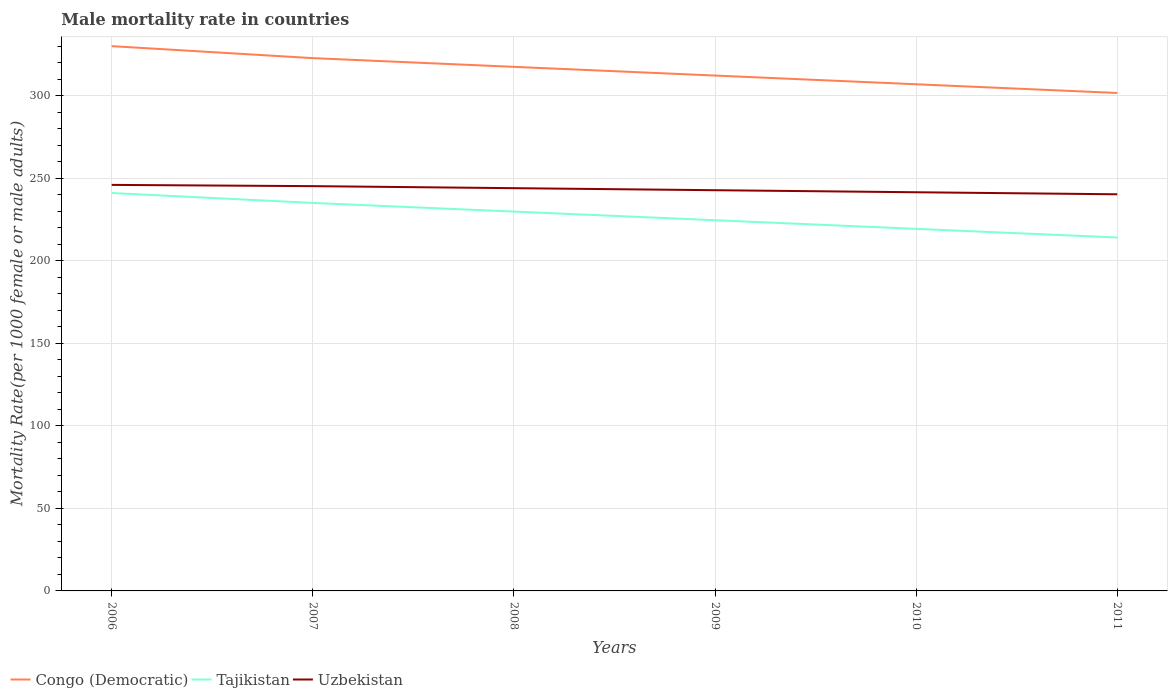Is the number of lines equal to the number of legend labels?
Provide a short and direct response. Yes. Across all years, what is the maximum male mortality rate in Uzbekistan?
Give a very brief answer. 240.42. What is the total male mortality rate in Uzbekistan in the graph?
Offer a terse response. 5.69. What is the difference between the highest and the second highest male mortality rate in Congo (Democratic)?
Keep it short and to the point. 28.38. Is the male mortality rate in Congo (Democratic) strictly greater than the male mortality rate in Uzbekistan over the years?
Ensure brevity in your answer.  No. How many lines are there?
Provide a short and direct response. 3. Does the graph contain any zero values?
Make the answer very short. No. Does the graph contain grids?
Offer a terse response. Yes. How many legend labels are there?
Provide a short and direct response. 3. What is the title of the graph?
Your answer should be very brief. Male mortality rate in countries. What is the label or title of the Y-axis?
Offer a terse response. Mortality Rate(per 1000 female or male adults). What is the Mortality Rate(per 1000 female or male adults) in Congo (Democratic) in 2006?
Provide a succinct answer. 330.21. What is the Mortality Rate(per 1000 female or male adults) of Tajikistan in 2006?
Keep it short and to the point. 241.19. What is the Mortality Rate(per 1000 female or male adults) in Uzbekistan in 2006?
Provide a succinct answer. 246.11. What is the Mortality Rate(per 1000 female or male adults) in Congo (Democratic) in 2007?
Your response must be concise. 322.95. What is the Mortality Rate(per 1000 female or male adults) of Tajikistan in 2007?
Give a very brief answer. 235.18. What is the Mortality Rate(per 1000 female or male adults) in Uzbekistan in 2007?
Offer a terse response. 245.36. What is the Mortality Rate(per 1000 female or male adults) of Congo (Democratic) in 2008?
Offer a terse response. 317.67. What is the Mortality Rate(per 1000 female or male adults) in Tajikistan in 2008?
Offer a terse response. 229.94. What is the Mortality Rate(per 1000 female or male adults) in Uzbekistan in 2008?
Your answer should be compact. 244.12. What is the Mortality Rate(per 1000 female or male adults) of Congo (Democratic) in 2009?
Offer a very short reply. 312.39. What is the Mortality Rate(per 1000 female or male adults) in Tajikistan in 2009?
Your answer should be compact. 224.7. What is the Mortality Rate(per 1000 female or male adults) of Uzbekistan in 2009?
Provide a succinct answer. 242.89. What is the Mortality Rate(per 1000 female or male adults) of Congo (Democratic) in 2010?
Provide a short and direct response. 307.11. What is the Mortality Rate(per 1000 female or male adults) of Tajikistan in 2010?
Offer a terse response. 219.47. What is the Mortality Rate(per 1000 female or male adults) in Uzbekistan in 2010?
Offer a very short reply. 241.65. What is the Mortality Rate(per 1000 female or male adults) of Congo (Democratic) in 2011?
Give a very brief answer. 301.83. What is the Mortality Rate(per 1000 female or male adults) in Tajikistan in 2011?
Your answer should be very brief. 214.23. What is the Mortality Rate(per 1000 female or male adults) of Uzbekistan in 2011?
Ensure brevity in your answer.  240.42. Across all years, what is the maximum Mortality Rate(per 1000 female or male adults) in Congo (Democratic)?
Ensure brevity in your answer.  330.21. Across all years, what is the maximum Mortality Rate(per 1000 female or male adults) of Tajikistan?
Ensure brevity in your answer.  241.19. Across all years, what is the maximum Mortality Rate(per 1000 female or male adults) in Uzbekistan?
Make the answer very short. 246.11. Across all years, what is the minimum Mortality Rate(per 1000 female or male adults) of Congo (Democratic)?
Make the answer very short. 301.83. Across all years, what is the minimum Mortality Rate(per 1000 female or male adults) of Tajikistan?
Keep it short and to the point. 214.23. Across all years, what is the minimum Mortality Rate(per 1000 female or male adults) of Uzbekistan?
Give a very brief answer. 240.42. What is the total Mortality Rate(per 1000 female or male adults) in Congo (Democratic) in the graph?
Provide a short and direct response. 1892.17. What is the total Mortality Rate(per 1000 female or male adults) in Tajikistan in the graph?
Provide a succinct answer. 1364.7. What is the total Mortality Rate(per 1000 female or male adults) in Uzbekistan in the graph?
Your answer should be very brief. 1460.56. What is the difference between the Mortality Rate(per 1000 female or male adults) in Congo (Democratic) in 2006 and that in 2007?
Give a very brief answer. 7.26. What is the difference between the Mortality Rate(per 1000 female or male adults) in Tajikistan in 2006 and that in 2007?
Provide a short and direct response. 6.01. What is the difference between the Mortality Rate(per 1000 female or male adults) of Uzbekistan in 2006 and that in 2007?
Provide a short and direct response. 0.75. What is the difference between the Mortality Rate(per 1000 female or male adults) in Congo (Democratic) in 2006 and that in 2008?
Your answer should be very brief. 12.54. What is the difference between the Mortality Rate(per 1000 female or male adults) in Tajikistan in 2006 and that in 2008?
Give a very brief answer. 11.25. What is the difference between the Mortality Rate(per 1000 female or male adults) of Uzbekistan in 2006 and that in 2008?
Give a very brief answer. 1.99. What is the difference between the Mortality Rate(per 1000 female or male adults) in Congo (Democratic) in 2006 and that in 2009?
Give a very brief answer. 17.82. What is the difference between the Mortality Rate(per 1000 female or male adults) in Tajikistan in 2006 and that in 2009?
Provide a succinct answer. 16.48. What is the difference between the Mortality Rate(per 1000 female or male adults) of Uzbekistan in 2006 and that in 2009?
Your response must be concise. 3.22. What is the difference between the Mortality Rate(per 1000 female or male adults) of Congo (Democratic) in 2006 and that in 2010?
Your answer should be very brief. 23.1. What is the difference between the Mortality Rate(per 1000 female or male adults) in Tajikistan in 2006 and that in 2010?
Keep it short and to the point. 21.72. What is the difference between the Mortality Rate(per 1000 female or male adults) of Uzbekistan in 2006 and that in 2010?
Your answer should be compact. 4.46. What is the difference between the Mortality Rate(per 1000 female or male adults) in Congo (Democratic) in 2006 and that in 2011?
Offer a terse response. 28.38. What is the difference between the Mortality Rate(per 1000 female or male adults) of Tajikistan in 2006 and that in 2011?
Your answer should be compact. 26.96. What is the difference between the Mortality Rate(per 1000 female or male adults) in Uzbekistan in 2006 and that in 2011?
Your answer should be compact. 5.69. What is the difference between the Mortality Rate(per 1000 female or male adults) in Congo (Democratic) in 2007 and that in 2008?
Offer a terse response. 5.28. What is the difference between the Mortality Rate(per 1000 female or male adults) in Tajikistan in 2007 and that in 2008?
Your answer should be compact. 5.24. What is the difference between the Mortality Rate(per 1000 female or male adults) in Uzbekistan in 2007 and that in 2008?
Keep it short and to the point. 1.24. What is the difference between the Mortality Rate(per 1000 female or male adults) of Congo (Democratic) in 2007 and that in 2009?
Ensure brevity in your answer.  10.56. What is the difference between the Mortality Rate(per 1000 female or male adults) of Tajikistan in 2007 and that in 2009?
Provide a succinct answer. 10.48. What is the difference between the Mortality Rate(per 1000 female or male adults) in Uzbekistan in 2007 and that in 2009?
Give a very brief answer. 2.47. What is the difference between the Mortality Rate(per 1000 female or male adults) in Congo (Democratic) in 2007 and that in 2010?
Make the answer very short. 15.84. What is the difference between the Mortality Rate(per 1000 female or male adults) of Tajikistan in 2007 and that in 2010?
Offer a terse response. 15.71. What is the difference between the Mortality Rate(per 1000 female or male adults) of Uzbekistan in 2007 and that in 2010?
Provide a succinct answer. 3.71. What is the difference between the Mortality Rate(per 1000 female or male adults) of Congo (Democratic) in 2007 and that in 2011?
Provide a short and direct response. 21.12. What is the difference between the Mortality Rate(per 1000 female or male adults) in Tajikistan in 2007 and that in 2011?
Keep it short and to the point. 20.95. What is the difference between the Mortality Rate(per 1000 female or male adults) in Uzbekistan in 2007 and that in 2011?
Give a very brief answer. 4.94. What is the difference between the Mortality Rate(per 1000 female or male adults) in Congo (Democratic) in 2008 and that in 2009?
Keep it short and to the point. 5.28. What is the difference between the Mortality Rate(per 1000 female or male adults) of Tajikistan in 2008 and that in 2009?
Your response must be concise. 5.24. What is the difference between the Mortality Rate(per 1000 female or male adults) of Uzbekistan in 2008 and that in 2009?
Give a very brief answer. 1.24. What is the difference between the Mortality Rate(per 1000 female or male adults) of Congo (Democratic) in 2008 and that in 2010?
Provide a short and direct response. 10.56. What is the difference between the Mortality Rate(per 1000 female or male adults) in Tajikistan in 2008 and that in 2010?
Your answer should be very brief. 10.47. What is the difference between the Mortality Rate(per 1000 female or male adults) of Uzbekistan in 2008 and that in 2010?
Ensure brevity in your answer.  2.47. What is the difference between the Mortality Rate(per 1000 female or male adults) in Congo (Democratic) in 2008 and that in 2011?
Provide a succinct answer. 15.84. What is the difference between the Mortality Rate(per 1000 female or male adults) of Tajikistan in 2008 and that in 2011?
Your answer should be very brief. 15.71. What is the difference between the Mortality Rate(per 1000 female or male adults) of Uzbekistan in 2008 and that in 2011?
Your answer should be very brief. 3.71. What is the difference between the Mortality Rate(per 1000 female or male adults) of Congo (Democratic) in 2009 and that in 2010?
Offer a very short reply. 5.28. What is the difference between the Mortality Rate(per 1000 female or male adults) of Tajikistan in 2009 and that in 2010?
Ensure brevity in your answer.  5.24. What is the difference between the Mortality Rate(per 1000 female or male adults) of Uzbekistan in 2009 and that in 2010?
Offer a very short reply. 1.24. What is the difference between the Mortality Rate(per 1000 female or male adults) of Congo (Democratic) in 2009 and that in 2011?
Provide a short and direct response. 10.56. What is the difference between the Mortality Rate(per 1000 female or male adults) in Tajikistan in 2009 and that in 2011?
Your response must be concise. 10.47. What is the difference between the Mortality Rate(per 1000 female or male adults) of Uzbekistan in 2009 and that in 2011?
Provide a succinct answer. 2.47. What is the difference between the Mortality Rate(per 1000 female or male adults) of Congo (Democratic) in 2010 and that in 2011?
Provide a short and direct response. 5.28. What is the difference between the Mortality Rate(per 1000 female or male adults) of Tajikistan in 2010 and that in 2011?
Offer a terse response. 5.24. What is the difference between the Mortality Rate(per 1000 female or male adults) in Uzbekistan in 2010 and that in 2011?
Offer a very short reply. 1.24. What is the difference between the Mortality Rate(per 1000 female or male adults) in Congo (Democratic) in 2006 and the Mortality Rate(per 1000 female or male adults) in Tajikistan in 2007?
Your answer should be compact. 95.04. What is the difference between the Mortality Rate(per 1000 female or male adults) in Congo (Democratic) in 2006 and the Mortality Rate(per 1000 female or male adults) in Uzbekistan in 2007?
Your answer should be very brief. 84.86. What is the difference between the Mortality Rate(per 1000 female or male adults) of Tajikistan in 2006 and the Mortality Rate(per 1000 female or male adults) of Uzbekistan in 2007?
Your answer should be compact. -4.17. What is the difference between the Mortality Rate(per 1000 female or male adults) in Congo (Democratic) in 2006 and the Mortality Rate(per 1000 female or male adults) in Tajikistan in 2008?
Your answer should be compact. 100.27. What is the difference between the Mortality Rate(per 1000 female or male adults) of Congo (Democratic) in 2006 and the Mortality Rate(per 1000 female or male adults) of Uzbekistan in 2008?
Offer a very short reply. 86.09. What is the difference between the Mortality Rate(per 1000 female or male adults) of Tajikistan in 2006 and the Mortality Rate(per 1000 female or male adults) of Uzbekistan in 2008?
Offer a terse response. -2.94. What is the difference between the Mortality Rate(per 1000 female or male adults) in Congo (Democratic) in 2006 and the Mortality Rate(per 1000 female or male adults) in Tajikistan in 2009?
Your answer should be very brief. 105.51. What is the difference between the Mortality Rate(per 1000 female or male adults) in Congo (Democratic) in 2006 and the Mortality Rate(per 1000 female or male adults) in Uzbekistan in 2009?
Offer a very short reply. 87.33. What is the difference between the Mortality Rate(per 1000 female or male adults) of Tajikistan in 2006 and the Mortality Rate(per 1000 female or male adults) of Uzbekistan in 2009?
Offer a very short reply. -1.7. What is the difference between the Mortality Rate(per 1000 female or male adults) in Congo (Democratic) in 2006 and the Mortality Rate(per 1000 female or male adults) in Tajikistan in 2010?
Provide a short and direct response. 110.75. What is the difference between the Mortality Rate(per 1000 female or male adults) of Congo (Democratic) in 2006 and the Mortality Rate(per 1000 female or male adults) of Uzbekistan in 2010?
Your answer should be very brief. 88.56. What is the difference between the Mortality Rate(per 1000 female or male adults) in Tajikistan in 2006 and the Mortality Rate(per 1000 female or male adults) in Uzbekistan in 2010?
Keep it short and to the point. -0.47. What is the difference between the Mortality Rate(per 1000 female or male adults) in Congo (Democratic) in 2006 and the Mortality Rate(per 1000 female or male adults) in Tajikistan in 2011?
Make the answer very short. 115.99. What is the difference between the Mortality Rate(per 1000 female or male adults) in Congo (Democratic) in 2006 and the Mortality Rate(per 1000 female or male adults) in Uzbekistan in 2011?
Give a very brief answer. 89.8. What is the difference between the Mortality Rate(per 1000 female or male adults) in Tajikistan in 2006 and the Mortality Rate(per 1000 female or male adults) in Uzbekistan in 2011?
Keep it short and to the point. 0.77. What is the difference between the Mortality Rate(per 1000 female or male adults) of Congo (Democratic) in 2007 and the Mortality Rate(per 1000 female or male adults) of Tajikistan in 2008?
Keep it short and to the point. 93.01. What is the difference between the Mortality Rate(per 1000 female or male adults) in Congo (Democratic) in 2007 and the Mortality Rate(per 1000 female or male adults) in Uzbekistan in 2008?
Keep it short and to the point. 78.83. What is the difference between the Mortality Rate(per 1000 female or male adults) in Tajikistan in 2007 and the Mortality Rate(per 1000 female or male adults) in Uzbekistan in 2008?
Your answer should be compact. -8.95. What is the difference between the Mortality Rate(per 1000 female or male adults) in Congo (Democratic) in 2007 and the Mortality Rate(per 1000 female or male adults) in Tajikistan in 2009?
Provide a succinct answer. 98.25. What is the difference between the Mortality Rate(per 1000 female or male adults) of Congo (Democratic) in 2007 and the Mortality Rate(per 1000 female or male adults) of Uzbekistan in 2009?
Provide a short and direct response. 80.06. What is the difference between the Mortality Rate(per 1000 female or male adults) in Tajikistan in 2007 and the Mortality Rate(per 1000 female or male adults) in Uzbekistan in 2009?
Ensure brevity in your answer.  -7.71. What is the difference between the Mortality Rate(per 1000 female or male adults) in Congo (Democratic) in 2007 and the Mortality Rate(per 1000 female or male adults) in Tajikistan in 2010?
Your answer should be very brief. 103.48. What is the difference between the Mortality Rate(per 1000 female or male adults) in Congo (Democratic) in 2007 and the Mortality Rate(per 1000 female or male adults) in Uzbekistan in 2010?
Offer a very short reply. 81.3. What is the difference between the Mortality Rate(per 1000 female or male adults) in Tajikistan in 2007 and the Mortality Rate(per 1000 female or male adults) in Uzbekistan in 2010?
Your response must be concise. -6.48. What is the difference between the Mortality Rate(per 1000 female or male adults) in Congo (Democratic) in 2007 and the Mortality Rate(per 1000 female or male adults) in Tajikistan in 2011?
Provide a short and direct response. 108.72. What is the difference between the Mortality Rate(per 1000 female or male adults) in Congo (Democratic) in 2007 and the Mortality Rate(per 1000 female or male adults) in Uzbekistan in 2011?
Your response must be concise. 82.53. What is the difference between the Mortality Rate(per 1000 female or male adults) in Tajikistan in 2007 and the Mortality Rate(per 1000 female or male adults) in Uzbekistan in 2011?
Your response must be concise. -5.24. What is the difference between the Mortality Rate(per 1000 female or male adults) of Congo (Democratic) in 2008 and the Mortality Rate(per 1000 female or male adults) of Tajikistan in 2009?
Provide a short and direct response. 92.97. What is the difference between the Mortality Rate(per 1000 female or male adults) in Congo (Democratic) in 2008 and the Mortality Rate(per 1000 female or male adults) in Uzbekistan in 2009?
Provide a short and direct response. 74.78. What is the difference between the Mortality Rate(per 1000 female or male adults) of Tajikistan in 2008 and the Mortality Rate(per 1000 female or male adults) of Uzbekistan in 2009?
Your response must be concise. -12.95. What is the difference between the Mortality Rate(per 1000 female or male adults) of Congo (Democratic) in 2008 and the Mortality Rate(per 1000 female or male adults) of Tajikistan in 2010?
Your response must be concise. 98.2. What is the difference between the Mortality Rate(per 1000 female or male adults) of Congo (Democratic) in 2008 and the Mortality Rate(per 1000 female or male adults) of Uzbekistan in 2010?
Ensure brevity in your answer.  76.02. What is the difference between the Mortality Rate(per 1000 female or male adults) of Tajikistan in 2008 and the Mortality Rate(per 1000 female or male adults) of Uzbekistan in 2010?
Keep it short and to the point. -11.71. What is the difference between the Mortality Rate(per 1000 female or male adults) of Congo (Democratic) in 2008 and the Mortality Rate(per 1000 female or male adults) of Tajikistan in 2011?
Your answer should be compact. 103.44. What is the difference between the Mortality Rate(per 1000 female or male adults) of Congo (Democratic) in 2008 and the Mortality Rate(per 1000 female or male adults) of Uzbekistan in 2011?
Offer a terse response. 77.25. What is the difference between the Mortality Rate(per 1000 female or male adults) in Tajikistan in 2008 and the Mortality Rate(per 1000 female or male adults) in Uzbekistan in 2011?
Offer a terse response. -10.48. What is the difference between the Mortality Rate(per 1000 female or male adults) in Congo (Democratic) in 2009 and the Mortality Rate(per 1000 female or male adults) in Tajikistan in 2010?
Make the answer very short. 92.92. What is the difference between the Mortality Rate(per 1000 female or male adults) of Congo (Democratic) in 2009 and the Mortality Rate(per 1000 female or male adults) of Uzbekistan in 2010?
Provide a succinct answer. 70.74. What is the difference between the Mortality Rate(per 1000 female or male adults) in Tajikistan in 2009 and the Mortality Rate(per 1000 female or male adults) in Uzbekistan in 2010?
Provide a succinct answer. -16.95. What is the difference between the Mortality Rate(per 1000 female or male adults) in Congo (Democratic) in 2009 and the Mortality Rate(per 1000 female or male adults) in Tajikistan in 2011?
Ensure brevity in your answer.  98.16. What is the difference between the Mortality Rate(per 1000 female or male adults) of Congo (Democratic) in 2009 and the Mortality Rate(per 1000 female or male adults) of Uzbekistan in 2011?
Provide a succinct answer. 71.97. What is the difference between the Mortality Rate(per 1000 female or male adults) in Tajikistan in 2009 and the Mortality Rate(per 1000 female or male adults) in Uzbekistan in 2011?
Make the answer very short. -15.72. What is the difference between the Mortality Rate(per 1000 female or male adults) in Congo (Democratic) in 2010 and the Mortality Rate(per 1000 female or male adults) in Tajikistan in 2011?
Offer a very short reply. 92.88. What is the difference between the Mortality Rate(per 1000 female or male adults) in Congo (Democratic) in 2010 and the Mortality Rate(per 1000 female or male adults) in Uzbekistan in 2011?
Your response must be concise. 66.69. What is the difference between the Mortality Rate(per 1000 female or male adults) in Tajikistan in 2010 and the Mortality Rate(per 1000 female or male adults) in Uzbekistan in 2011?
Make the answer very short. -20.95. What is the average Mortality Rate(per 1000 female or male adults) of Congo (Democratic) per year?
Offer a terse response. 315.36. What is the average Mortality Rate(per 1000 female or male adults) of Tajikistan per year?
Keep it short and to the point. 227.45. What is the average Mortality Rate(per 1000 female or male adults) of Uzbekistan per year?
Your response must be concise. 243.43. In the year 2006, what is the difference between the Mortality Rate(per 1000 female or male adults) of Congo (Democratic) and Mortality Rate(per 1000 female or male adults) of Tajikistan?
Provide a short and direct response. 89.03. In the year 2006, what is the difference between the Mortality Rate(per 1000 female or male adults) of Congo (Democratic) and Mortality Rate(per 1000 female or male adults) of Uzbekistan?
Keep it short and to the point. 84.1. In the year 2006, what is the difference between the Mortality Rate(per 1000 female or male adults) in Tajikistan and Mortality Rate(per 1000 female or male adults) in Uzbekistan?
Offer a very short reply. -4.92. In the year 2007, what is the difference between the Mortality Rate(per 1000 female or male adults) of Congo (Democratic) and Mortality Rate(per 1000 female or male adults) of Tajikistan?
Offer a very short reply. 87.77. In the year 2007, what is the difference between the Mortality Rate(per 1000 female or male adults) in Congo (Democratic) and Mortality Rate(per 1000 female or male adults) in Uzbekistan?
Offer a terse response. 77.59. In the year 2007, what is the difference between the Mortality Rate(per 1000 female or male adults) in Tajikistan and Mortality Rate(per 1000 female or male adults) in Uzbekistan?
Provide a short and direct response. -10.18. In the year 2008, what is the difference between the Mortality Rate(per 1000 female or male adults) of Congo (Democratic) and Mortality Rate(per 1000 female or male adults) of Tajikistan?
Provide a short and direct response. 87.73. In the year 2008, what is the difference between the Mortality Rate(per 1000 female or male adults) of Congo (Democratic) and Mortality Rate(per 1000 female or male adults) of Uzbekistan?
Keep it short and to the point. 73.55. In the year 2008, what is the difference between the Mortality Rate(per 1000 female or male adults) in Tajikistan and Mortality Rate(per 1000 female or male adults) in Uzbekistan?
Your answer should be very brief. -14.18. In the year 2009, what is the difference between the Mortality Rate(per 1000 female or male adults) of Congo (Democratic) and Mortality Rate(per 1000 female or male adults) of Tajikistan?
Your answer should be compact. 87.69. In the year 2009, what is the difference between the Mortality Rate(per 1000 female or male adults) of Congo (Democratic) and Mortality Rate(per 1000 female or male adults) of Uzbekistan?
Give a very brief answer. 69.5. In the year 2009, what is the difference between the Mortality Rate(per 1000 female or male adults) in Tajikistan and Mortality Rate(per 1000 female or male adults) in Uzbekistan?
Ensure brevity in your answer.  -18.19. In the year 2010, what is the difference between the Mortality Rate(per 1000 female or male adults) of Congo (Democratic) and Mortality Rate(per 1000 female or male adults) of Tajikistan?
Provide a short and direct response. 87.65. In the year 2010, what is the difference between the Mortality Rate(per 1000 female or male adults) of Congo (Democratic) and Mortality Rate(per 1000 female or male adults) of Uzbekistan?
Offer a terse response. 65.46. In the year 2010, what is the difference between the Mortality Rate(per 1000 female or male adults) of Tajikistan and Mortality Rate(per 1000 female or male adults) of Uzbekistan?
Ensure brevity in your answer.  -22.19. In the year 2011, what is the difference between the Mortality Rate(per 1000 female or male adults) of Congo (Democratic) and Mortality Rate(per 1000 female or male adults) of Tajikistan?
Provide a short and direct response. 87.6. In the year 2011, what is the difference between the Mortality Rate(per 1000 female or male adults) in Congo (Democratic) and Mortality Rate(per 1000 female or male adults) in Uzbekistan?
Ensure brevity in your answer.  61.41. In the year 2011, what is the difference between the Mortality Rate(per 1000 female or male adults) in Tajikistan and Mortality Rate(per 1000 female or male adults) in Uzbekistan?
Keep it short and to the point. -26.19. What is the ratio of the Mortality Rate(per 1000 female or male adults) of Congo (Democratic) in 2006 to that in 2007?
Offer a terse response. 1.02. What is the ratio of the Mortality Rate(per 1000 female or male adults) in Tajikistan in 2006 to that in 2007?
Make the answer very short. 1.03. What is the ratio of the Mortality Rate(per 1000 female or male adults) of Uzbekistan in 2006 to that in 2007?
Offer a very short reply. 1. What is the ratio of the Mortality Rate(per 1000 female or male adults) of Congo (Democratic) in 2006 to that in 2008?
Provide a short and direct response. 1.04. What is the ratio of the Mortality Rate(per 1000 female or male adults) of Tajikistan in 2006 to that in 2008?
Your answer should be compact. 1.05. What is the ratio of the Mortality Rate(per 1000 female or male adults) in Uzbekistan in 2006 to that in 2008?
Your response must be concise. 1.01. What is the ratio of the Mortality Rate(per 1000 female or male adults) of Congo (Democratic) in 2006 to that in 2009?
Your response must be concise. 1.06. What is the ratio of the Mortality Rate(per 1000 female or male adults) in Tajikistan in 2006 to that in 2009?
Give a very brief answer. 1.07. What is the ratio of the Mortality Rate(per 1000 female or male adults) in Uzbekistan in 2006 to that in 2009?
Provide a succinct answer. 1.01. What is the ratio of the Mortality Rate(per 1000 female or male adults) in Congo (Democratic) in 2006 to that in 2010?
Provide a short and direct response. 1.08. What is the ratio of the Mortality Rate(per 1000 female or male adults) of Tajikistan in 2006 to that in 2010?
Your answer should be very brief. 1.1. What is the ratio of the Mortality Rate(per 1000 female or male adults) in Uzbekistan in 2006 to that in 2010?
Give a very brief answer. 1.02. What is the ratio of the Mortality Rate(per 1000 female or male adults) in Congo (Democratic) in 2006 to that in 2011?
Keep it short and to the point. 1.09. What is the ratio of the Mortality Rate(per 1000 female or male adults) of Tajikistan in 2006 to that in 2011?
Offer a terse response. 1.13. What is the ratio of the Mortality Rate(per 1000 female or male adults) in Uzbekistan in 2006 to that in 2011?
Give a very brief answer. 1.02. What is the ratio of the Mortality Rate(per 1000 female or male adults) of Congo (Democratic) in 2007 to that in 2008?
Your response must be concise. 1.02. What is the ratio of the Mortality Rate(per 1000 female or male adults) of Tajikistan in 2007 to that in 2008?
Offer a terse response. 1.02. What is the ratio of the Mortality Rate(per 1000 female or male adults) of Congo (Democratic) in 2007 to that in 2009?
Provide a succinct answer. 1.03. What is the ratio of the Mortality Rate(per 1000 female or male adults) in Tajikistan in 2007 to that in 2009?
Offer a terse response. 1.05. What is the ratio of the Mortality Rate(per 1000 female or male adults) of Uzbekistan in 2007 to that in 2009?
Offer a very short reply. 1.01. What is the ratio of the Mortality Rate(per 1000 female or male adults) of Congo (Democratic) in 2007 to that in 2010?
Offer a terse response. 1.05. What is the ratio of the Mortality Rate(per 1000 female or male adults) in Tajikistan in 2007 to that in 2010?
Your answer should be compact. 1.07. What is the ratio of the Mortality Rate(per 1000 female or male adults) in Uzbekistan in 2007 to that in 2010?
Offer a terse response. 1.02. What is the ratio of the Mortality Rate(per 1000 female or male adults) in Congo (Democratic) in 2007 to that in 2011?
Your answer should be very brief. 1.07. What is the ratio of the Mortality Rate(per 1000 female or male adults) in Tajikistan in 2007 to that in 2011?
Ensure brevity in your answer.  1.1. What is the ratio of the Mortality Rate(per 1000 female or male adults) of Uzbekistan in 2007 to that in 2011?
Offer a terse response. 1.02. What is the ratio of the Mortality Rate(per 1000 female or male adults) of Congo (Democratic) in 2008 to that in 2009?
Offer a terse response. 1.02. What is the ratio of the Mortality Rate(per 1000 female or male adults) in Tajikistan in 2008 to that in 2009?
Make the answer very short. 1.02. What is the ratio of the Mortality Rate(per 1000 female or male adults) of Congo (Democratic) in 2008 to that in 2010?
Provide a short and direct response. 1.03. What is the ratio of the Mortality Rate(per 1000 female or male adults) in Tajikistan in 2008 to that in 2010?
Make the answer very short. 1.05. What is the ratio of the Mortality Rate(per 1000 female or male adults) of Uzbekistan in 2008 to that in 2010?
Offer a very short reply. 1.01. What is the ratio of the Mortality Rate(per 1000 female or male adults) in Congo (Democratic) in 2008 to that in 2011?
Offer a terse response. 1.05. What is the ratio of the Mortality Rate(per 1000 female or male adults) in Tajikistan in 2008 to that in 2011?
Offer a very short reply. 1.07. What is the ratio of the Mortality Rate(per 1000 female or male adults) of Uzbekistan in 2008 to that in 2011?
Offer a very short reply. 1.02. What is the ratio of the Mortality Rate(per 1000 female or male adults) of Congo (Democratic) in 2009 to that in 2010?
Provide a succinct answer. 1.02. What is the ratio of the Mortality Rate(per 1000 female or male adults) in Tajikistan in 2009 to that in 2010?
Give a very brief answer. 1.02. What is the ratio of the Mortality Rate(per 1000 female or male adults) in Congo (Democratic) in 2009 to that in 2011?
Give a very brief answer. 1.03. What is the ratio of the Mortality Rate(per 1000 female or male adults) in Tajikistan in 2009 to that in 2011?
Provide a short and direct response. 1.05. What is the ratio of the Mortality Rate(per 1000 female or male adults) of Uzbekistan in 2009 to that in 2011?
Keep it short and to the point. 1.01. What is the ratio of the Mortality Rate(per 1000 female or male adults) in Congo (Democratic) in 2010 to that in 2011?
Your answer should be very brief. 1.02. What is the ratio of the Mortality Rate(per 1000 female or male adults) of Tajikistan in 2010 to that in 2011?
Offer a very short reply. 1.02. What is the ratio of the Mortality Rate(per 1000 female or male adults) in Uzbekistan in 2010 to that in 2011?
Your answer should be compact. 1.01. What is the difference between the highest and the second highest Mortality Rate(per 1000 female or male adults) in Congo (Democratic)?
Offer a terse response. 7.26. What is the difference between the highest and the second highest Mortality Rate(per 1000 female or male adults) of Tajikistan?
Keep it short and to the point. 6.01. What is the difference between the highest and the second highest Mortality Rate(per 1000 female or male adults) in Uzbekistan?
Keep it short and to the point. 0.75. What is the difference between the highest and the lowest Mortality Rate(per 1000 female or male adults) of Congo (Democratic)?
Give a very brief answer. 28.38. What is the difference between the highest and the lowest Mortality Rate(per 1000 female or male adults) in Tajikistan?
Provide a short and direct response. 26.96. What is the difference between the highest and the lowest Mortality Rate(per 1000 female or male adults) in Uzbekistan?
Your response must be concise. 5.69. 